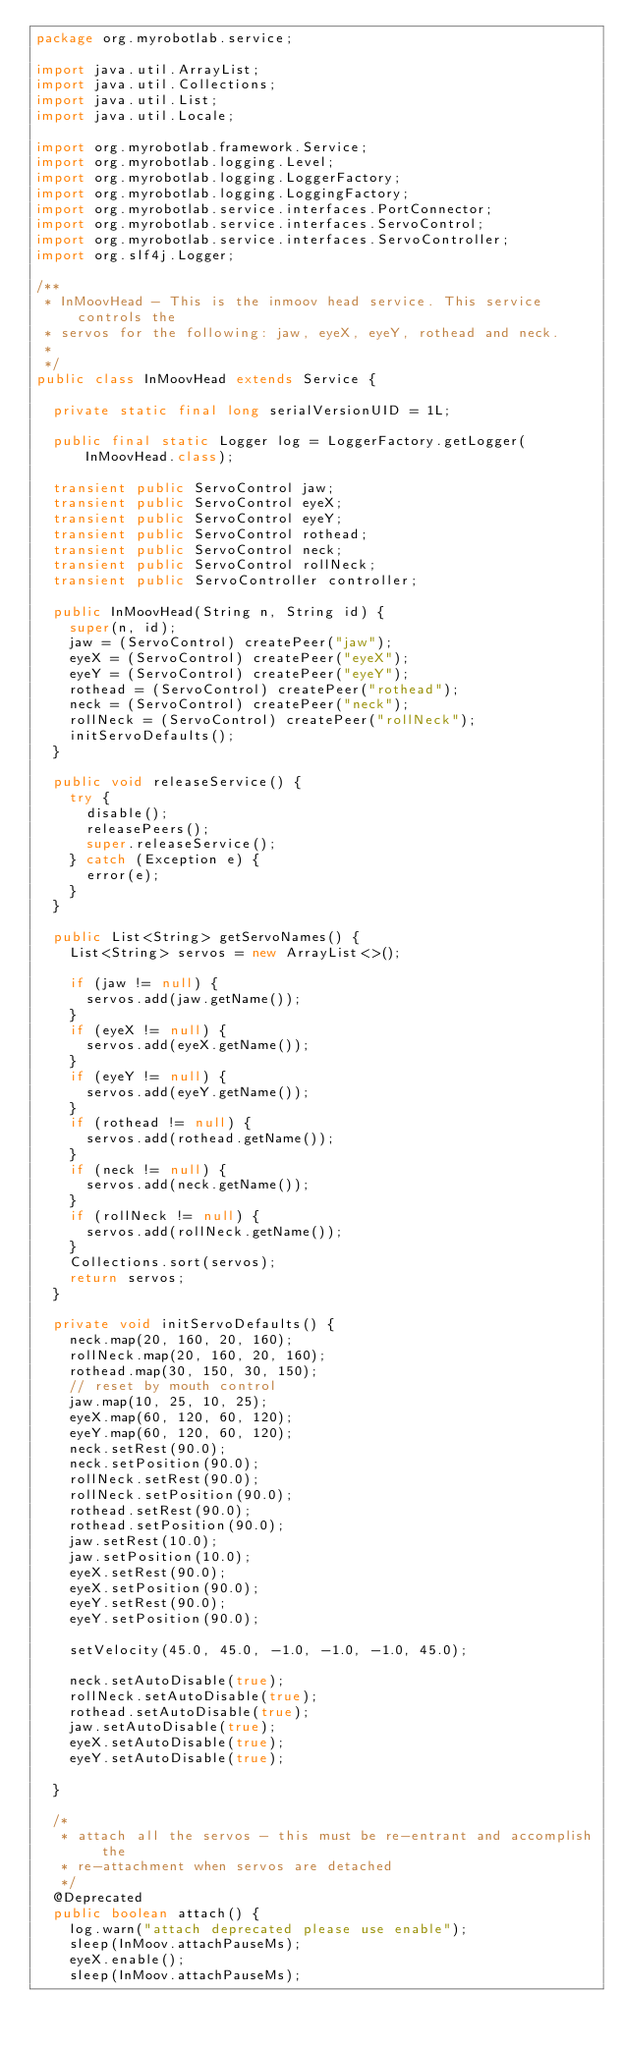<code> <loc_0><loc_0><loc_500><loc_500><_Java_>package org.myrobotlab.service;

import java.util.ArrayList;
import java.util.Collections;
import java.util.List;
import java.util.Locale;

import org.myrobotlab.framework.Service;
import org.myrobotlab.logging.Level;
import org.myrobotlab.logging.LoggerFactory;
import org.myrobotlab.logging.LoggingFactory;
import org.myrobotlab.service.interfaces.PortConnector;
import org.myrobotlab.service.interfaces.ServoControl;
import org.myrobotlab.service.interfaces.ServoController;
import org.slf4j.Logger;

/**
 * InMoovHead - This is the inmoov head service. This service controls the
 * servos for the following: jaw, eyeX, eyeY, rothead and neck.
 * 
 */
public class InMoovHead extends Service {

  private static final long serialVersionUID = 1L;

  public final static Logger log = LoggerFactory.getLogger(InMoovHead.class);

  transient public ServoControl jaw;
  transient public ServoControl eyeX;
  transient public ServoControl eyeY;
  transient public ServoControl rothead;
  transient public ServoControl neck;
  transient public ServoControl rollNeck;
  transient public ServoController controller;

  public InMoovHead(String n, String id) {
    super(n, id);
    jaw = (ServoControl) createPeer("jaw");
    eyeX = (ServoControl) createPeer("eyeX");
    eyeY = (ServoControl) createPeer("eyeY");
    rothead = (ServoControl) createPeer("rothead");
    neck = (ServoControl) createPeer("neck");
    rollNeck = (ServoControl) createPeer("rollNeck");
    initServoDefaults();
  }

  public void releaseService() {
    try {
      disable();
      releasePeers();
      super.releaseService();
    } catch (Exception e) {
      error(e);
    }
  }

  public List<String> getServoNames() {
    List<String> servos = new ArrayList<>();

    if (jaw != null) {
      servos.add(jaw.getName());
    }
    if (eyeX != null) {
      servos.add(eyeX.getName());
    }
    if (eyeY != null) {
      servos.add(eyeY.getName());
    }
    if (rothead != null) {
      servos.add(rothead.getName());
    }
    if (neck != null) {
      servos.add(neck.getName());
    }
    if (rollNeck != null) {
      servos.add(rollNeck.getName());
    }
    Collections.sort(servos);
    return servos;
  }

  private void initServoDefaults() {
    neck.map(20, 160, 20, 160);
    rollNeck.map(20, 160, 20, 160);
    rothead.map(30, 150, 30, 150);
    // reset by mouth control
    jaw.map(10, 25, 10, 25);
    eyeX.map(60, 120, 60, 120);
    eyeY.map(60, 120, 60, 120);
    neck.setRest(90.0);
    neck.setPosition(90.0);
    rollNeck.setRest(90.0);
    rollNeck.setPosition(90.0);
    rothead.setRest(90.0);
    rothead.setPosition(90.0);
    jaw.setRest(10.0);
    jaw.setPosition(10.0);
    eyeX.setRest(90.0);
    eyeX.setPosition(90.0);
    eyeY.setRest(90.0);
    eyeY.setPosition(90.0);

    setVelocity(45.0, 45.0, -1.0, -1.0, -1.0, 45.0);

    neck.setAutoDisable(true);
    rollNeck.setAutoDisable(true);
    rothead.setAutoDisable(true);
    jaw.setAutoDisable(true);
    eyeX.setAutoDisable(true);
    eyeY.setAutoDisable(true);

  }

  /*
   * attach all the servos - this must be re-entrant and accomplish the
   * re-attachment when servos are detached
   */
  @Deprecated
  public boolean attach() {
    log.warn("attach deprecated please use enable");
    sleep(InMoov.attachPauseMs);
    eyeX.enable();
    sleep(InMoov.attachPauseMs);</code> 